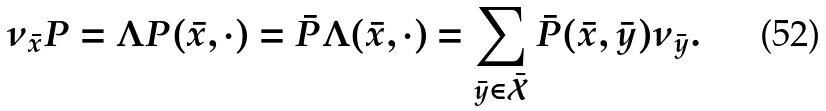Convert formula to latex. <formula><loc_0><loc_0><loc_500><loc_500>\nu _ { \bar { x } } P = \Lambda P ( \bar { x } , \cdot ) = \bar { P } \Lambda ( \bar { x } , \cdot ) = \sum _ { \bar { y } \in \bar { \mathcal { X } } } \bar { P } ( \bar { x } , \bar { y } ) \nu _ { \bar { y } } .</formula> 